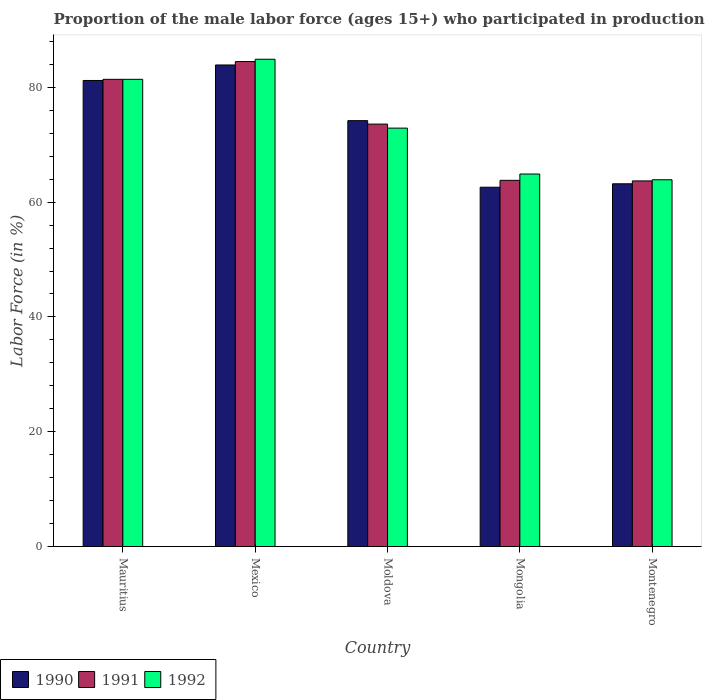How many different coloured bars are there?
Offer a terse response. 3. How many bars are there on the 3rd tick from the left?
Offer a terse response. 3. What is the label of the 3rd group of bars from the left?
Ensure brevity in your answer.  Moldova. In how many cases, is the number of bars for a given country not equal to the number of legend labels?
Your response must be concise. 0. What is the proportion of the male labor force who participated in production in 1991 in Mauritius?
Offer a terse response. 81.4. Across all countries, what is the maximum proportion of the male labor force who participated in production in 1990?
Give a very brief answer. 83.9. Across all countries, what is the minimum proportion of the male labor force who participated in production in 1992?
Keep it short and to the point. 63.9. In which country was the proportion of the male labor force who participated in production in 1992 maximum?
Ensure brevity in your answer.  Mexico. In which country was the proportion of the male labor force who participated in production in 1992 minimum?
Offer a terse response. Montenegro. What is the total proportion of the male labor force who participated in production in 1991 in the graph?
Keep it short and to the point. 367. What is the difference between the proportion of the male labor force who participated in production in 1991 in Mauritius and that in Mexico?
Your answer should be very brief. -3.1. What is the difference between the proportion of the male labor force who participated in production in 1992 in Mauritius and the proportion of the male labor force who participated in production in 1990 in Montenegro?
Your answer should be compact. 18.2. What is the average proportion of the male labor force who participated in production in 1990 per country?
Provide a succinct answer. 73.02. What is the ratio of the proportion of the male labor force who participated in production in 1991 in Mauritius to that in Montenegro?
Your answer should be compact. 1.28. Is the proportion of the male labor force who participated in production in 1990 in Mongolia less than that in Montenegro?
Offer a very short reply. Yes. Is the difference between the proportion of the male labor force who participated in production in 1991 in Mexico and Moldova greater than the difference between the proportion of the male labor force who participated in production in 1990 in Mexico and Moldova?
Offer a terse response. Yes. What is the difference between the highest and the second highest proportion of the male labor force who participated in production in 1991?
Give a very brief answer. -7.8. What is the difference between the highest and the lowest proportion of the male labor force who participated in production in 1990?
Provide a succinct answer. 21.3. In how many countries, is the proportion of the male labor force who participated in production in 1992 greater than the average proportion of the male labor force who participated in production in 1992 taken over all countries?
Make the answer very short. 2. What does the 3rd bar from the left in Montenegro represents?
Offer a very short reply. 1992. What does the 1st bar from the right in Mongolia represents?
Your answer should be very brief. 1992. Is it the case that in every country, the sum of the proportion of the male labor force who participated in production in 1990 and proportion of the male labor force who participated in production in 1992 is greater than the proportion of the male labor force who participated in production in 1991?
Provide a succinct answer. Yes. How many bars are there?
Provide a succinct answer. 15. Are all the bars in the graph horizontal?
Your response must be concise. No. How many countries are there in the graph?
Your answer should be compact. 5. Are the values on the major ticks of Y-axis written in scientific E-notation?
Offer a very short reply. No. Does the graph contain any zero values?
Offer a terse response. No. Where does the legend appear in the graph?
Ensure brevity in your answer.  Bottom left. How are the legend labels stacked?
Provide a short and direct response. Horizontal. What is the title of the graph?
Keep it short and to the point. Proportion of the male labor force (ages 15+) who participated in production. What is the Labor Force (in %) of 1990 in Mauritius?
Your answer should be very brief. 81.2. What is the Labor Force (in %) in 1991 in Mauritius?
Your response must be concise. 81.4. What is the Labor Force (in %) in 1992 in Mauritius?
Your response must be concise. 81.4. What is the Labor Force (in %) in 1990 in Mexico?
Make the answer very short. 83.9. What is the Labor Force (in %) in 1991 in Mexico?
Provide a short and direct response. 84.5. What is the Labor Force (in %) of 1992 in Mexico?
Make the answer very short. 84.9. What is the Labor Force (in %) of 1990 in Moldova?
Provide a succinct answer. 74.2. What is the Labor Force (in %) of 1991 in Moldova?
Ensure brevity in your answer.  73.6. What is the Labor Force (in %) of 1992 in Moldova?
Offer a very short reply. 72.9. What is the Labor Force (in %) of 1990 in Mongolia?
Provide a succinct answer. 62.6. What is the Labor Force (in %) in 1991 in Mongolia?
Your answer should be compact. 63.8. What is the Labor Force (in %) in 1992 in Mongolia?
Your answer should be compact. 64.9. What is the Labor Force (in %) in 1990 in Montenegro?
Keep it short and to the point. 63.2. What is the Labor Force (in %) in 1991 in Montenegro?
Your answer should be very brief. 63.7. What is the Labor Force (in %) in 1992 in Montenegro?
Make the answer very short. 63.9. Across all countries, what is the maximum Labor Force (in %) in 1990?
Make the answer very short. 83.9. Across all countries, what is the maximum Labor Force (in %) of 1991?
Keep it short and to the point. 84.5. Across all countries, what is the maximum Labor Force (in %) of 1992?
Provide a succinct answer. 84.9. Across all countries, what is the minimum Labor Force (in %) in 1990?
Give a very brief answer. 62.6. Across all countries, what is the minimum Labor Force (in %) in 1991?
Offer a terse response. 63.7. Across all countries, what is the minimum Labor Force (in %) of 1992?
Offer a very short reply. 63.9. What is the total Labor Force (in %) of 1990 in the graph?
Provide a succinct answer. 365.1. What is the total Labor Force (in %) of 1991 in the graph?
Make the answer very short. 367. What is the total Labor Force (in %) of 1992 in the graph?
Your answer should be very brief. 368. What is the difference between the Labor Force (in %) of 1991 in Mauritius and that in Mexico?
Ensure brevity in your answer.  -3.1. What is the difference between the Labor Force (in %) of 1991 in Mauritius and that in Moldova?
Your answer should be compact. 7.8. What is the difference between the Labor Force (in %) of 1992 in Mauritius and that in Moldova?
Your response must be concise. 8.5. What is the difference between the Labor Force (in %) in 1990 in Mauritius and that in Mongolia?
Offer a terse response. 18.6. What is the difference between the Labor Force (in %) of 1991 in Mauritius and that in Mongolia?
Offer a very short reply. 17.6. What is the difference between the Labor Force (in %) in 1992 in Mauritius and that in Mongolia?
Offer a terse response. 16.5. What is the difference between the Labor Force (in %) of 1990 in Mauritius and that in Montenegro?
Give a very brief answer. 18. What is the difference between the Labor Force (in %) in 1991 in Mauritius and that in Montenegro?
Give a very brief answer. 17.7. What is the difference between the Labor Force (in %) of 1992 in Mexico and that in Moldova?
Your answer should be very brief. 12. What is the difference between the Labor Force (in %) in 1990 in Mexico and that in Mongolia?
Provide a succinct answer. 21.3. What is the difference between the Labor Force (in %) in 1991 in Mexico and that in Mongolia?
Your response must be concise. 20.7. What is the difference between the Labor Force (in %) of 1992 in Mexico and that in Mongolia?
Offer a very short reply. 20. What is the difference between the Labor Force (in %) in 1990 in Mexico and that in Montenegro?
Offer a terse response. 20.7. What is the difference between the Labor Force (in %) in 1991 in Mexico and that in Montenegro?
Provide a succinct answer. 20.8. What is the difference between the Labor Force (in %) of 1990 in Moldova and that in Mongolia?
Provide a short and direct response. 11.6. What is the difference between the Labor Force (in %) in 1992 in Moldova and that in Mongolia?
Ensure brevity in your answer.  8. What is the difference between the Labor Force (in %) in 1990 in Moldova and that in Montenegro?
Offer a very short reply. 11. What is the difference between the Labor Force (in %) in 1992 in Moldova and that in Montenegro?
Give a very brief answer. 9. What is the difference between the Labor Force (in %) of 1990 in Mauritius and the Labor Force (in %) of 1992 in Mexico?
Your response must be concise. -3.7. What is the difference between the Labor Force (in %) in 1991 in Mauritius and the Labor Force (in %) in 1992 in Moldova?
Offer a terse response. 8.5. What is the difference between the Labor Force (in %) in 1990 in Mauritius and the Labor Force (in %) in 1992 in Mongolia?
Your response must be concise. 16.3. What is the difference between the Labor Force (in %) in 1991 in Mauritius and the Labor Force (in %) in 1992 in Mongolia?
Make the answer very short. 16.5. What is the difference between the Labor Force (in %) in 1990 in Mexico and the Labor Force (in %) in 1992 in Moldova?
Offer a terse response. 11. What is the difference between the Labor Force (in %) of 1991 in Mexico and the Labor Force (in %) of 1992 in Moldova?
Your answer should be compact. 11.6. What is the difference between the Labor Force (in %) in 1990 in Mexico and the Labor Force (in %) in 1991 in Mongolia?
Give a very brief answer. 20.1. What is the difference between the Labor Force (in %) of 1990 in Mexico and the Labor Force (in %) of 1992 in Mongolia?
Give a very brief answer. 19. What is the difference between the Labor Force (in %) in 1991 in Mexico and the Labor Force (in %) in 1992 in Mongolia?
Make the answer very short. 19.6. What is the difference between the Labor Force (in %) of 1990 in Mexico and the Labor Force (in %) of 1991 in Montenegro?
Provide a succinct answer. 20.2. What is the difference between the Labor Force (in %) of 1990 in Mexico and the Labor Force (in %) of 1992 in Montenegro?
Give a very brief answer. 20. What is the difference between the Labor Force (in %) of 1991 in Mexico and the Labor Force (in %) of 1992 in Montenegro?
Give a very brief answer. 20.6. What is the difference between the Labor Force (in %) in 1991 in Moldova and the Labor Force (in %) in 1992 in Mongolia?
Your answer should be very brief. 8.7. What is the difference between the Labor Force (in %) of 1990 in Moldova and the Labor Force (in %) of 1991 in Montenegro?
Your answer should be compact. 10.5. What is the difference between the Labor Force (in %) of 1991 in Mongolia and the Labor Force (in %) of 1992 in Montenegro?
Ensure brevity in your answer.  -0.1. What is the average Labor Force (in %) in 1990 per country?
Your answer should be very brief. 73.02. What is the average Labor Force (in %) of 1991 per country?
Give a very brief answer. 73.4. What is the average Labor Force (in %) in 1992 per country?
Offer a very short reply. 73.6. What is the difference between the Labor Force (in %) in 1990 and Labor Force (in %) in 1992 in Mauritius?
Offer a terse response. -0.2. What is the difference between the Labor Force (in %) in 1991 and Labor Force (in %) in 1992 in Mauritius?
Your answer should be compact. 0. What is the difference between the Labor Force (in %) in 1991 and Labor Force (in %) in 1992 in Mexico?
Make the answer very short. -0.4. What is the difference between the Labor Force (in %) in 1990 and Labor Force (in %) in 1991 in Mongolia?
Provide a succinct answer. -1.2. What is the difference between the Labor Force (in %) of 1990 and Labor Force (in %) of 1992 in Montenegro?
Keep it short and to the point. -0.7. What is the ratio of the Labor Force (in %) of 1990 in Mauritius to that in Mexico?
Your answer should be very brief. 0.97. What is the ratio of the Labor Force (in %) of 1991 in Mauritius to that in Mexico?
Offer a terse response. 0.96. What is the ratio of the Labor Force (in %) of 1992 in Mauritius to that in Mexico?
Give a very brief answer. 0.96. What is the ratio of the Labor Force (in %) in 1990 in Mauritius to that in Moldova?
Your response must be concise. 1.09. What is the ratio of the Labor Force (in %) in 1991 in Mauritius to that in Moldova?
Your response must be concise. 1.11. What is the ratio of the Labor Force (in %) of 1992 in Mauritius to that in Moldova?
Your answer should be very brief. 1.12. What is the ratio of the Labor Force (in %) of 1990 in Mauritius to that in Mongolia?
Provide a succinct answer. 1.3. What is the ratio of the Labor Force (in %) in 1991 in Mauritius to that in Mongolia?
Provide a succinct answer. 1.28. What is the ratio of the Labor Force (in %) of 1992 in Mauritius to that in Mongolia?
Give a very brief answer. 1.25. What is the ratio of the Labor Force (in %) in 1990 in Mauritius to that in Montenegro?
Offer a very short reply. 1.28. What is the ratio of the Labor Force (in %) of 1991 in Mauritius to that in Montenegro?
Provide a succinct answer. 1.28. What is the ratio of the Labor Force (in %) in 1992 in Mauritius to that in Montenegro?
Provide a succinct answer. 1.27. What is the ratio of the Labor Force (in %) of 1990 in Mexico to that in Moldova?
Offer a very short reply. 1.13. What is the ratio of the Labor Force (in %) in 1991 in Mexico to that in Moldova?
Provide a short and direct response. 1.15. What is the ratio of the Labor Force (in %) of 1992 in Mexico to that in Moldova?
Make the answer very short. 1.16. What is the ratio of the Labor Force (in %) in 1990 in Mexico to that in Mongolia?
Keep it short and to the point. 1.34. What is the ratio of the Labor Force (in %) of 1991 in Mexico to that in Mongolia?
Your answer should be very brief. 1.32. What is the ratio of the Labor Force (in %) in 1992 in Mexico to that in Mongolia?
Offer a terse response. 1.31. What is the ratio of the Labor Force (in %) in 1990 in Mexico to that in Montenegro?
Keep it short and to the point. 1.33. What is the ratio of the Labor Force (in %) in 1991 in Mexico to that in Montenegro?
Provide a short and direct response. 1.33. What is the ratio of the Labor Force (in %) of 1992 in Mexico to that in Montenegro?
Ensure brevity in your answer.  1.33. What is the ratio of the Labor Force (in %) of 1990 in Moldova to that in Mongolia?
Provide a succinct answer. 1.19. What is the ratio of the Labor Force (in %) of 1991 in Moldova to that in Mongolia?
Your answer should be very brief. 1.15. What is the ratio of the Labor Force (in %) in 1992 in Moldova to that in Mongolia?
Your answer should be compact. 1.12. What is the ratio of the Labor Force (in %) of 1990 in Moldova to that in Montenegro?
Provide a short and direct response. 1.17. What is the ratio of the Labor Force (in %) in 1991 in Moldova to that in Montenegro?
Your response must be concise. 1.16. What is the ratio of the Labor Force (in %) in 1992 in Moldova to that in Montenegro?
Your answer should be compact. 1.14. What is the ratio of the Labor Force (in %) of 1990 in Mongolia to that in Montenegro?
Your answer should be compact. 0.99. What is the ratio of the Labor Force (in %) of 1991 in Mongolia to that in Montenegro?
Offer a terse response. 1. What is the ratio of the Labor Force (in %) in 1992 in Mongolia to that in Montenegro?
Give a very brief answer. 1.02. What is the difference between the highest and the second highest Labor Force (in %) in 1992?
Make the answer very short. 3.5. What is the difference between the highest and the lowest Labor Force (in %) in 1990?
Give a very brief answer. 21.3. What is the difference between the highest and the lowest Labor Force (in %) in 1991?
Your answer should be compact. 20.8. What is the difference between the highest and the lowest Labor Force (in %) of 1992?
Give a very brief answer. 21. 